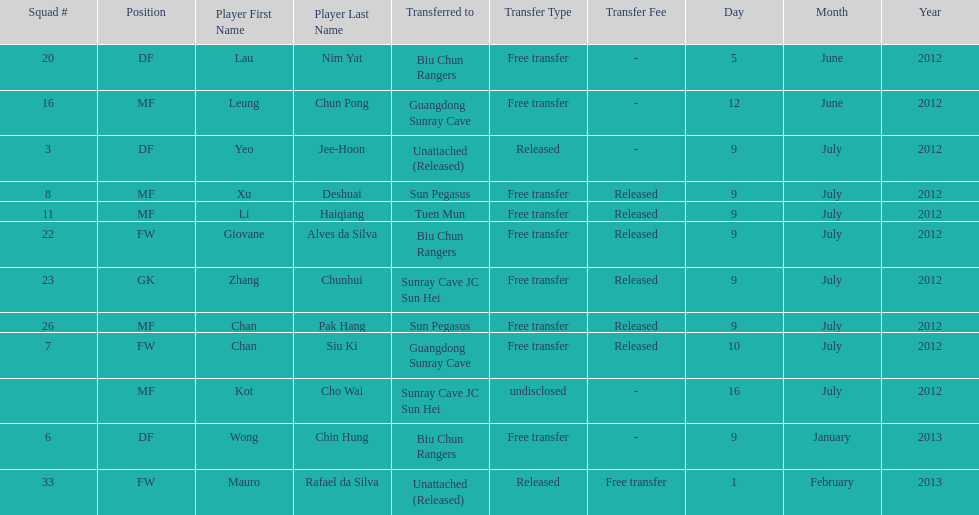Wong chin hung was transferred to his new team on what date? 9 January 2013. 